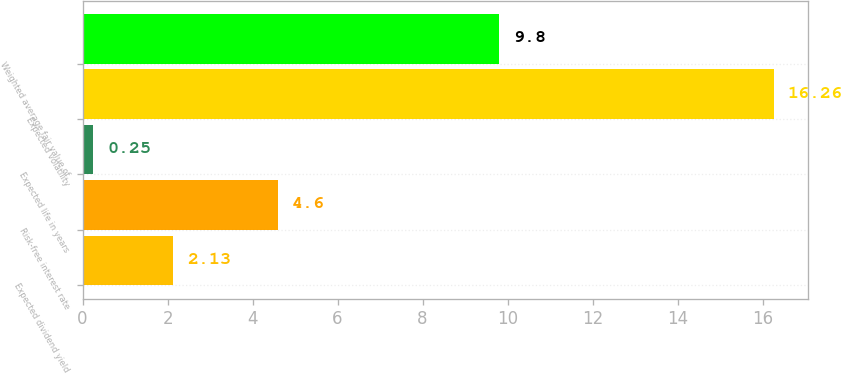Convert chart. <chart><loc_0><loc_0><loc_500><loc_500><bar_chart><fcel>Expected dividend yield<fcel>Risk-free interest rate<fcel>Expected life in years<fcel>Expected volatility<fcel>Weighted average fair value of<nl><fcel>2.13<fcel>4.6<fcel>0.25<fcel>16.26<fcel>9.8<nl></chart> 